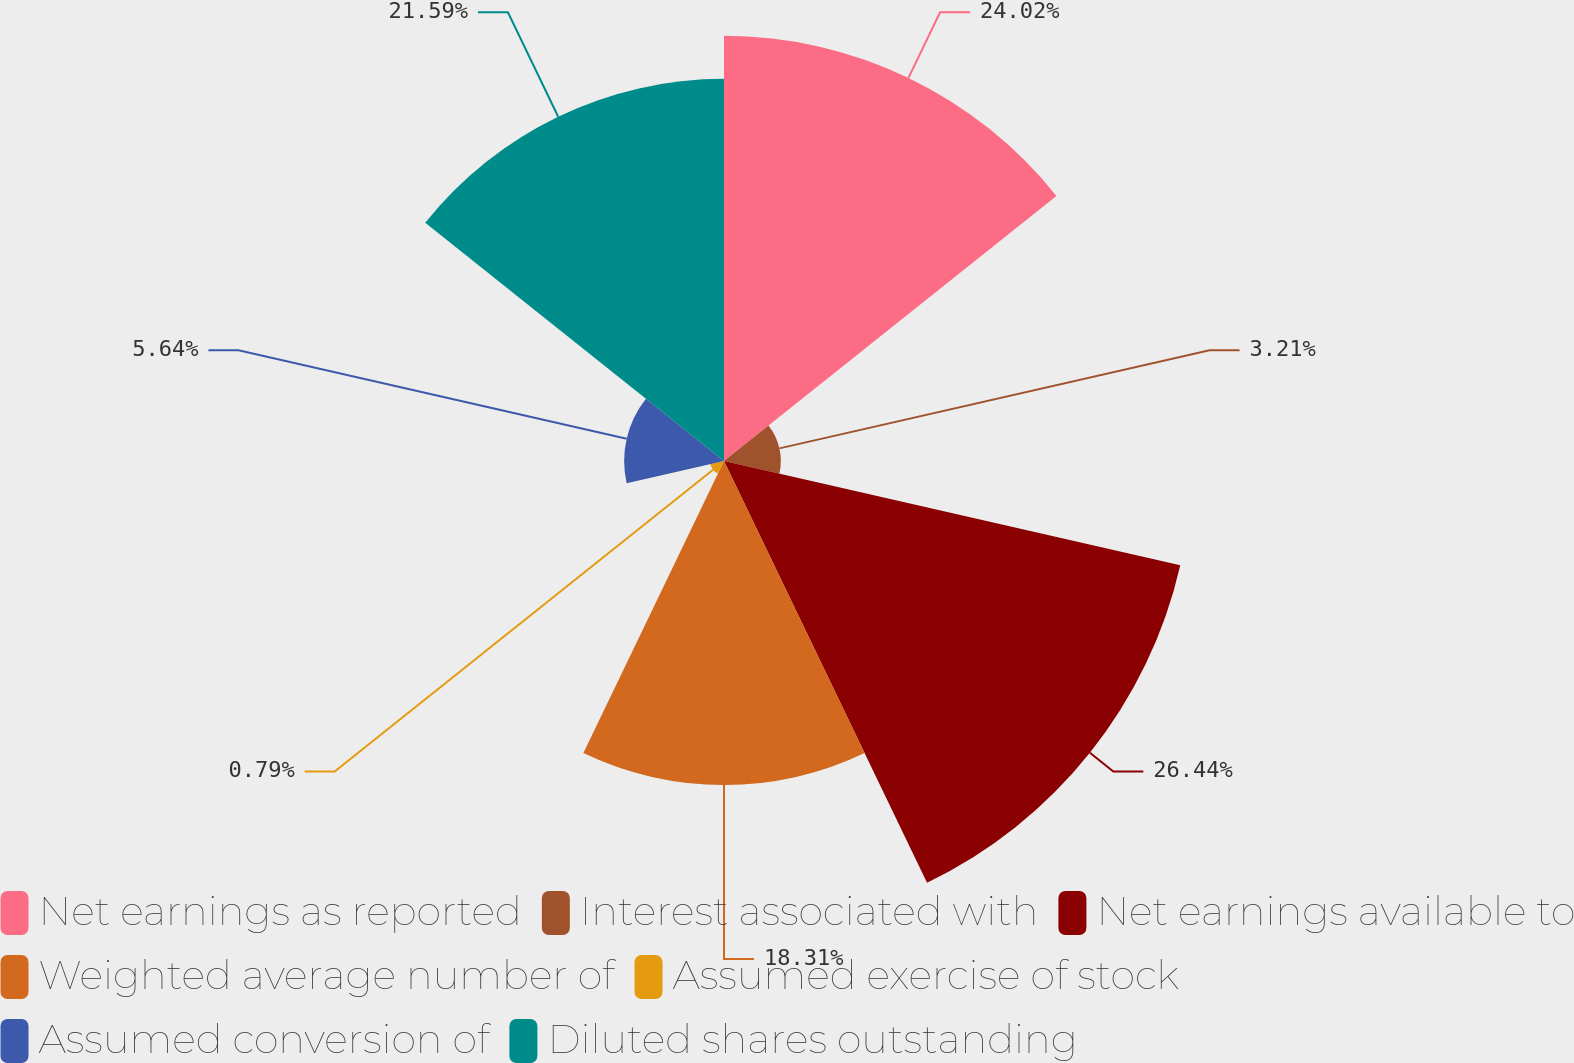Convert chart. <chart><loc_0><loc_0><loc_500><loc_500><pie_chart><fcel>Net earnings as reported<fcel>Interest associated with<fcel>Net earnings available to<fcel>Weighted average number of<fcel>Assumed exercise of stock<fcel>Assumed conversion of<fcel>Diluted shares outstanding<nl><fcel>24.02%<fcel>3.21%<fcel>26.44%<fcel>18.31%<fcel>0.79%<fcel>5.64%<fcel>21.59%<nl></chart> 